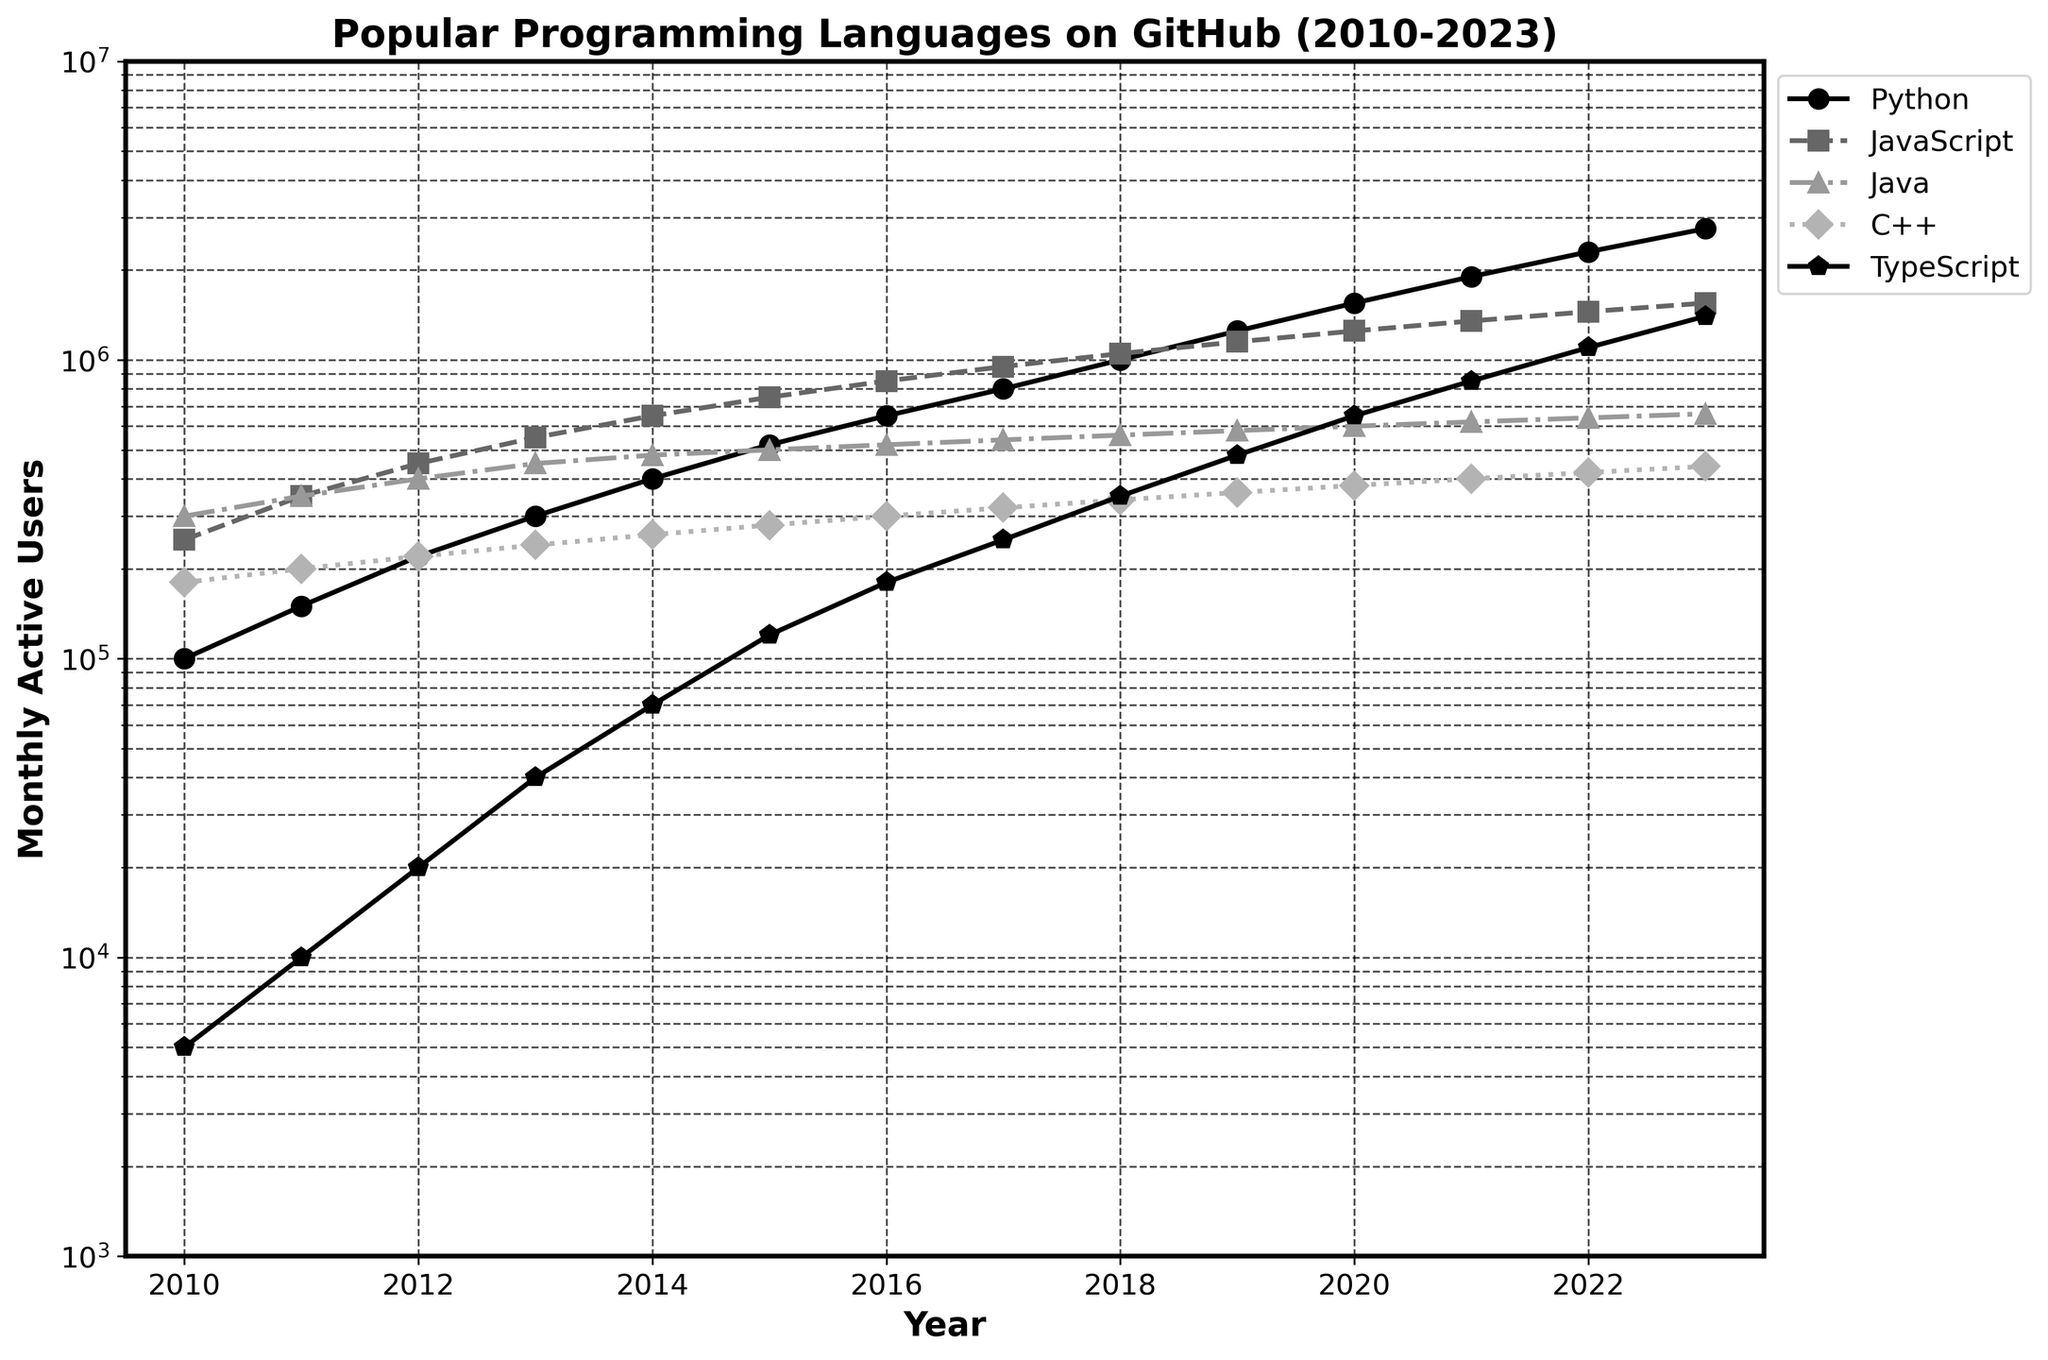What is the trend of Python's monthly active users from 2010 to 2023? Observe the curve with markers representing Python; note the increasing values from 100,000 to 2,750,000, showing a steady upward trend.
Answer: Increasing Which programming language had the highest number of monthly active users in 2023? Compare the terminal points of all lines. Python's value is the highest at 2,750,000.
Answer: Python During which year did TypeScript's monthly active users first exceed Java's? Compare the TypeScript and Java lines year by year. In 2018, TypeScript surpassed Java when it reached 350,000 while Java was at 340,000.
Answer: 2018 What is the range of monthly active users for JavaScript from 2010 to 2023? Find the minimum and maximum values for JavaScript within the given period: 250,000 in 2010 and 1,550,000 in 2023. Subtract to get the range.
Answer: 1,300,000 How does the growth of TypeScript's monthly active users compare to the other languages shown? Look at the slope of the TypeScript line, which initially is much steeper than others (especially from 2016 onwards), indicating faster growth relative to other languages during that period.
Answer: Faster growth Between 2010 and 2023, which year saw the largest increase in Python's monthly active users? Compute the year-over-year differences in Python's values and identify the largest, which occurred between 2021 (1,900,000) and 2022 (2,300,000), an increase of 400,000.
Answer: 2022 What is the average number of monthly active users for C++ in the years 2010, 2013, and 2023? Add C++ values for those years: 180,000 (2010), 240,000 (2013), 440,000 (2023); then divide by 3. (180,000 + 240,000 + 440,000)/3 = 860,000/3.
Answer: 286,667 Did any programming language's monthly active users decline at any point during the period? Examine all lines, noting that all are increasing, meaning there are no declines.
Answer: No Which language had the closest number of monthly active users to C++ in 2020? Compare C++'s 2020 value (380,000) to others in the same year. Go's 380,000 is exactly the same.
Answer: Go Does Ruby ever surpass PHP in terms of monthly active users from 2010 to 2023? Observe the lines of Ruby and PHP, noting that Ruby's line is consistently below PHP's throughout the period.
Answer: No 